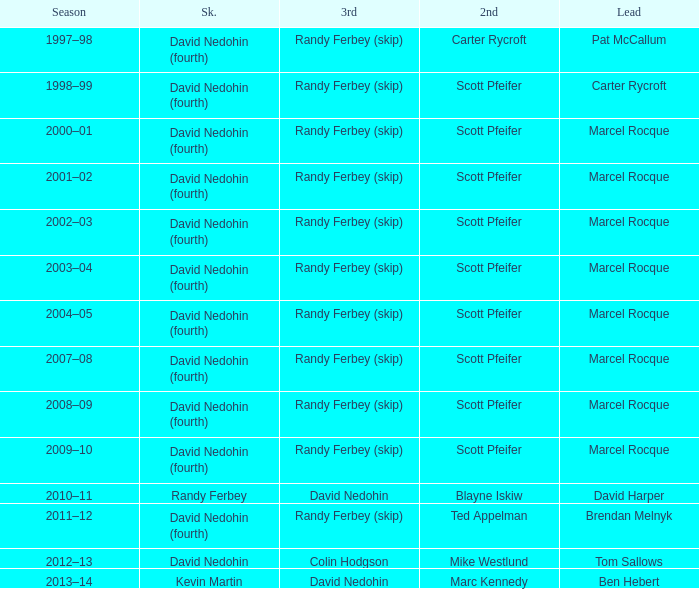Help me parse the entirety of this table. {'header': ['Season', 'Sk.', '3rd', '2nd', 'Lead'], 'rows': [['1997–98', 'David Nedohin (fourth)', 'Randy Ferbey (skip)', 'Carter Rycroft', 'Pat McCallum'], ['1998–99', 'David Nedohin (fourth)', 'Randy Ferbey (skip)', 'Scott Pfeifer', 'Carter Rycroft'], ['2000–01', 'David Nedohin (fourth)', 'Randy Ferbey (skip)', 'Scott Pfeifer', 'Marcel Rocque'], ['2001–02', 'David Nedohin (fourth)', 'Randy Ferbey (skip)', 'Scott Pfeifer', 'Marcel Rocque'], ['2002–03', 'David Nedohin (fourth)', 'Randy Ferbey (skip)', 'Scott Pfeifer', 'Marcel Rocque'], ['2003–04', 'David Nedohin (fourth)', 'Randy Ferbey (skip)', 'Scott Pfeifer', 'Marcel Rocque'], ['2004–05', 'David Nedohin (fourth)', 'Randy Ferbey (skip)', 'Scott Pfeifer', 'Marcel Rocque'], ['2007–08', 'David Nedohin (fourth)', 'Randy Ferbey (skip)', 'Scott Pfeifer', 'Marcel Rocque'], ['2008–09', 'David Nedohin (fourth)', 'Randy Ferbey (skip)', 'Scott Pfeifer', 'Marcel Rocque'], ['2009–10', 'David Nedohin (fourth)', 'Randy Ferbey (skip)', 'Scott Pfeifer', 'Marcel Rocque'], ['2010–11', 'Randy Ferbey', 'David Nedohin', 'Blayne Iskiw', 'David Harper'], ['2011–12', 'David Nedohin (fourth)', 'Randy Ferbey (skip)', 'Ted Appelman', 'Brendan Melnyk'], ['2012–13', 'David Nedohin', 'Colin Hodgson', 'Mike Westlund', 'Tom Sallows'], ['2013–14', 'Kevin Martin', 'David Nedohin', 'Marc Kennedy', 'Ben Hebert']]} Which Second has a Lead of ben hebert? Marc Kennedy. 